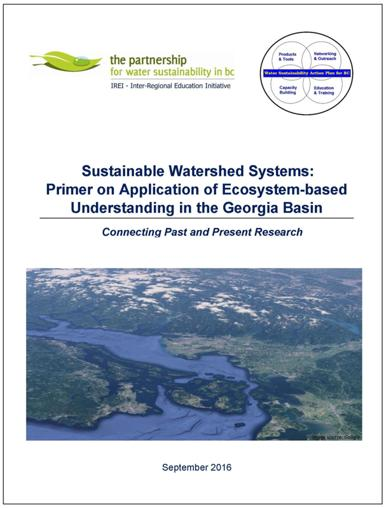What is the main focus of this publication? The primary focus of this publication is to foster an ecosystem-based understanding as it applies to sustainable watershed systems, with a particular emphasis on the Georgia Basin. It seeks to synthesize and connect historical and current research in a way that supports practitioners and policymakers in promoting watershed resilience and sustainability. 